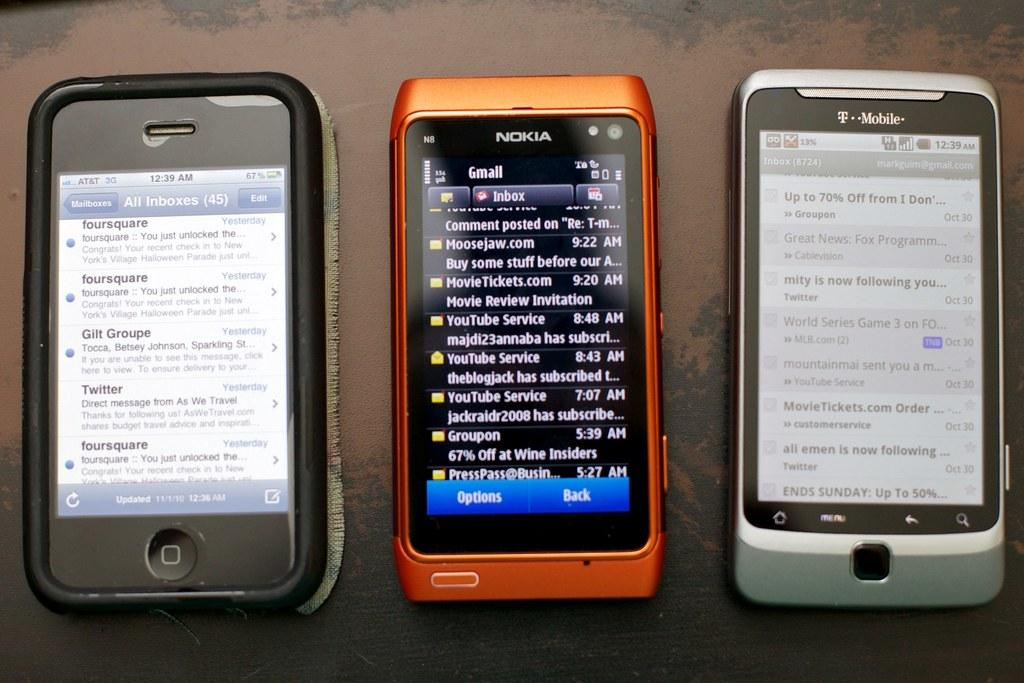<image>
Describe the image concisely. three cell phones by Nokia and T-Mobile on a table 